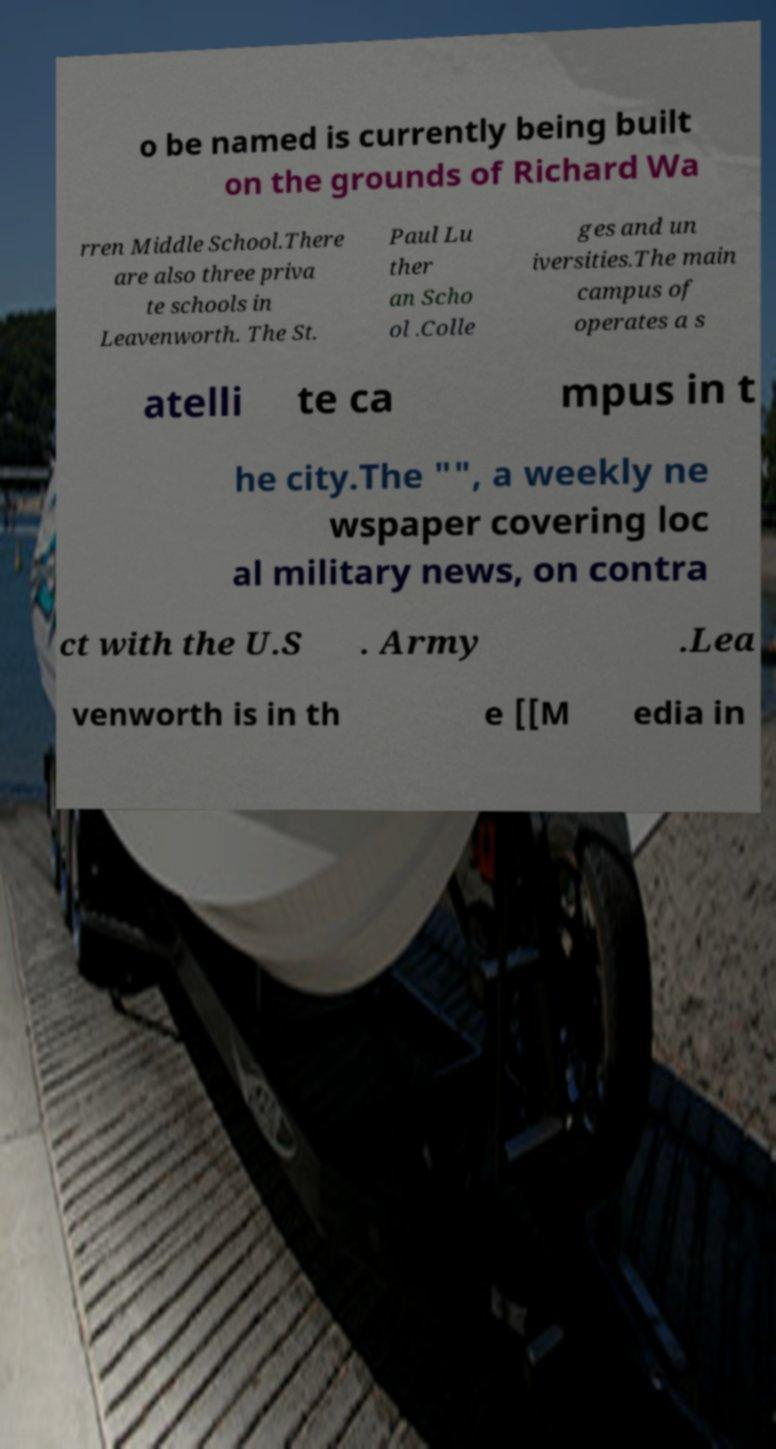What messages or text are displayed in this image? I need them in a readable, typed format. o be named is currently being built on the grounds of Richard Wa rren Middle School.There are also three priva te schools in Leavenworth. The St. Paul Lu ther an Scho ol .Colle ges and un iversities.The main campus of operates a s atelli te ca mpus in t he city.The "", a weekly ne wspaper covering loc al military news, on contra ct with the U.S . Army .Lea venworth is in th e [[M edia in 